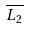Convert formula to latex. <formula><loc_0><loc_0><loc_500><loc_500>\overline { L _ { 2 } }</formula> 